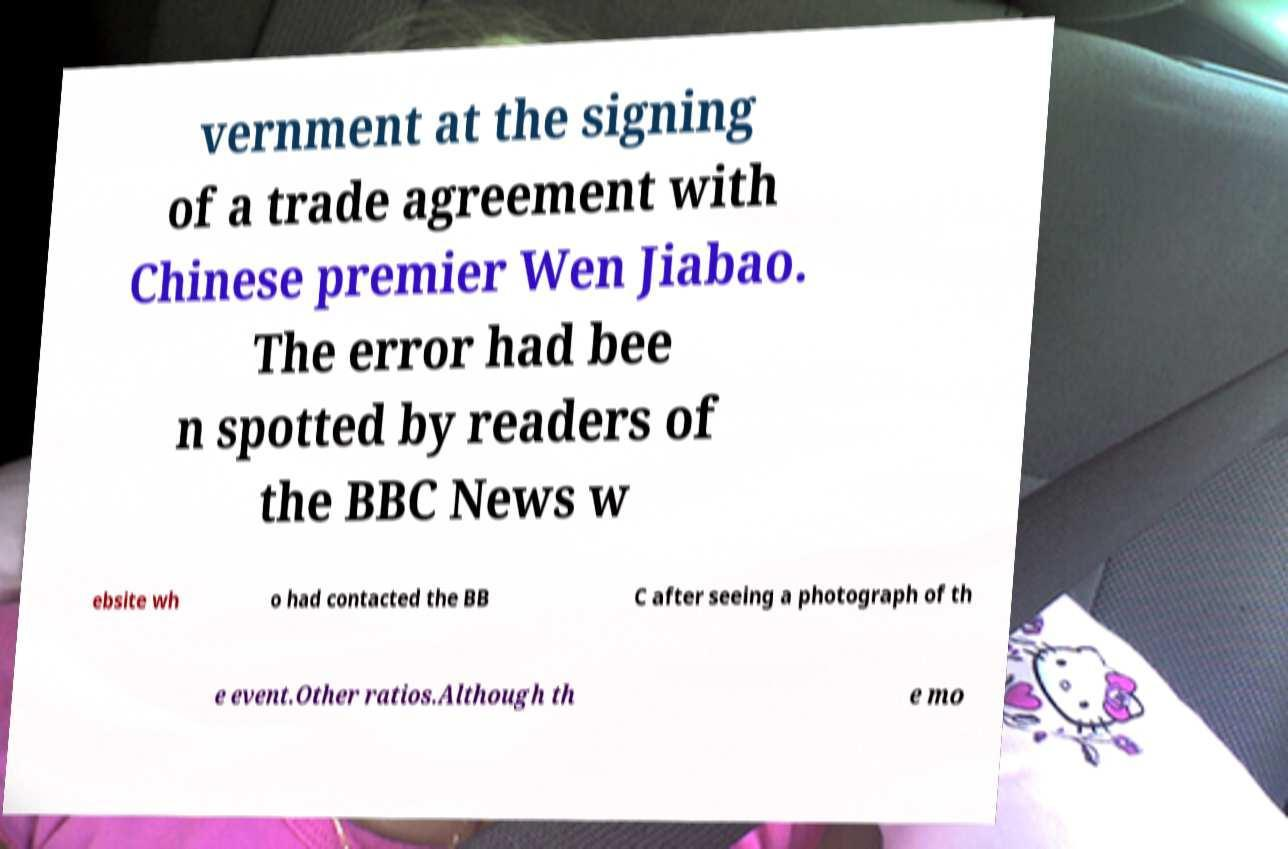Please identify and transcribe the text found in this image. vernment at the signing of a trade agreement with Chinese premier Wen Jiabao. The error had bee n spotted by readers of the BBC News w ebsite wh o had contacted the BB C after seeing a photograph of th e event.Other ratios.Although th e mo 